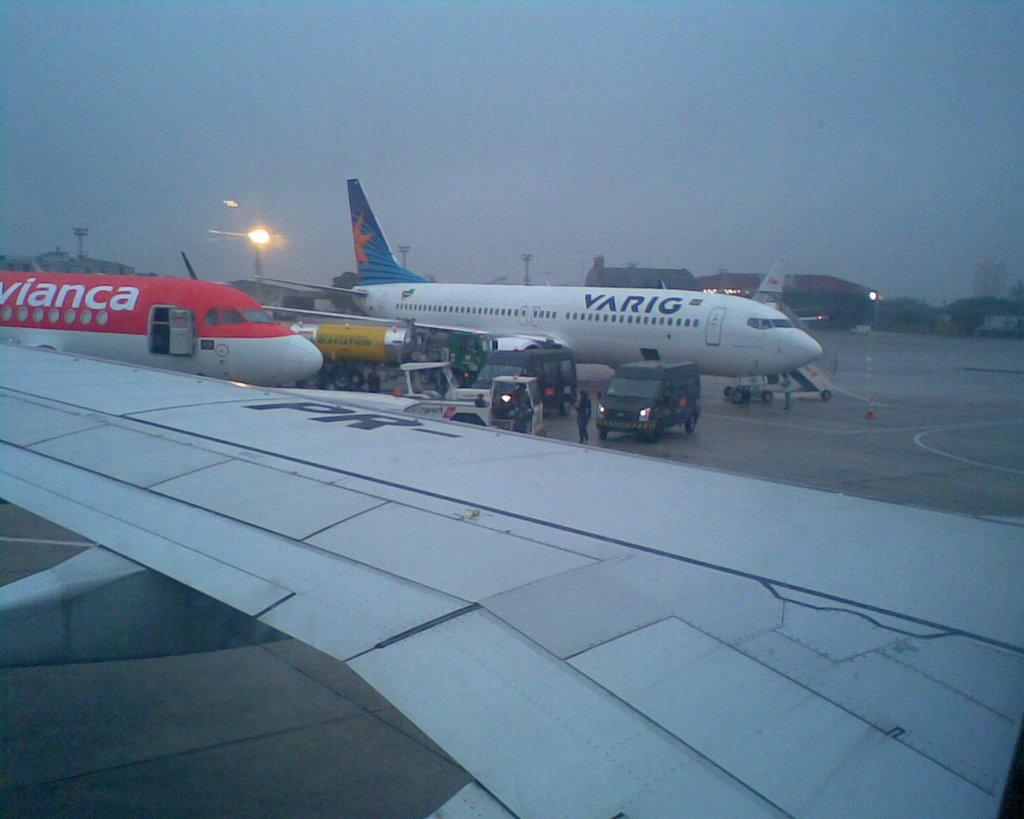What is the main subject of the image? The main subject of the image is airplanes. What other objects or elements can be seen in the image? There are vehicles and people standing in the image. What can be seen in the background of the image? There is a shed, lights, and a clear sky in the background of the image. How many brothers are standing near the airplanes in the image? There is no mention of brothers in the image, so we cannot determine the number of brothers present. 